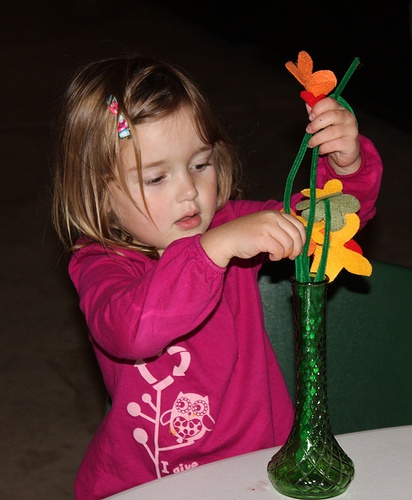Describe the objects in this image and their specific colors. I can see people in black, brown, maroon, and lightpink tones and vase in black and darkgreen tones in this image. 